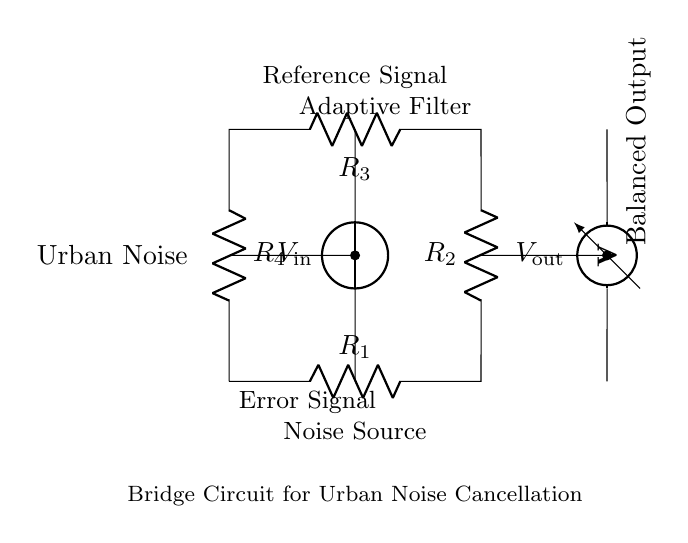What type of circuit is this? This circuit is a bridge circuit, specifically designed for noise cancellation. The structure and arrangement of resistors create a balanced configuration essential for the operation of adaptive filters in sound systems.
Answer: Bridge circuit How many resistors are in the circuit? There are four resistors in the circuit, labeled R1, R2, R3, and R4. Each resistor is crucial for establishing the balance needed for noise cancellation.
Answer: Four What does V_in represent in the circuit? V_in represents the input voltage, which is the potential difference supplied to the circuit for noise detection and cancellation. It connects the noise source to the circuit.
Answer: Input voltage What is the purpose of the voltmeter in this circuit? The voltmeter measures the output voltage, V_out, which reflects the effectiveness of the noise cancellation process by indicating the voltage after the noise has been filtered.
Answer: Measure output voltage What kind of signal does the circuit process? The circuit processes an urban noise signal, which enters the bridge circuit to be canceled out by the balanced output generated by the adaptive filter.
Answer: Urban noise What is the desired outcome of using this balanced bridge circuit? The desired outcome is to achieve a balanced output that effectively cancels out the noise present. This is critical in urban sound systems where noise pollution can adversely affect communities.
Answer: Noise cancellation How does the adaptive filter function in this circuit? The adaptive filter adjusts the resistances based on the noise levels, creating a dynamic response that optimizes the output voltage to minimize noise. This adjustment allows for real-time cancellation of varying noise inputs.
Answer: Adjusts resistances 